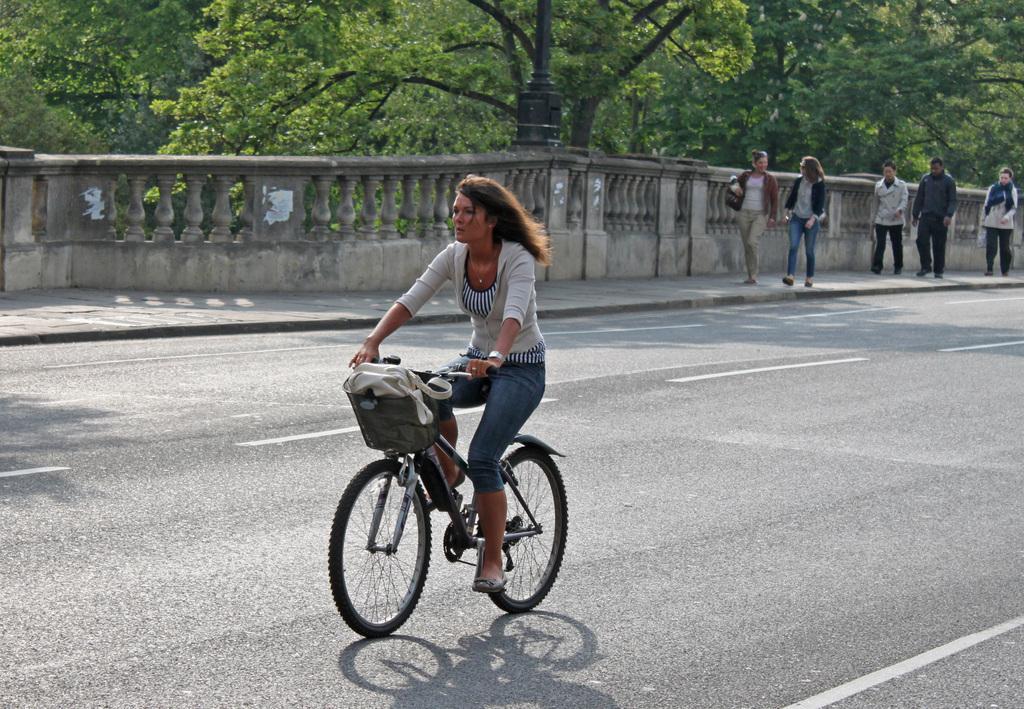Please provide a concise description of this image. In this picture there is a woman riding bicycle on the road and there some people walking on the side of the road and there is there are some trees in the backdrop. 